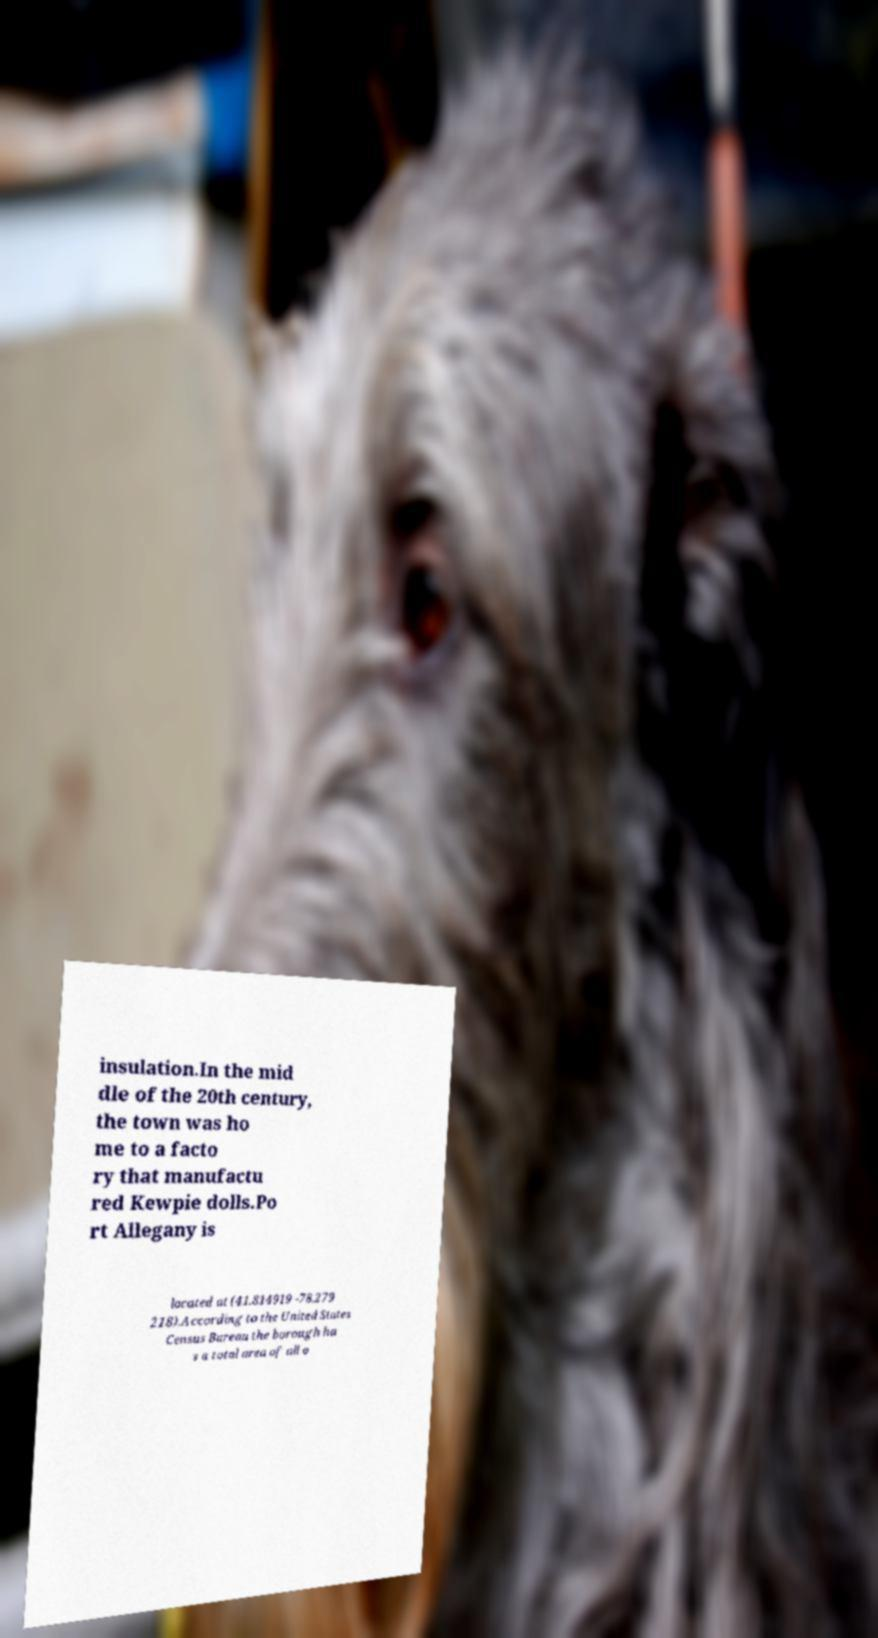Can you read and provide the text displayed in the image?This photo seems to have some interesting text. Can you extract and type it out for me? insulation.In the mid dle of the 20th century, the town was ho me to a facto ry that manufactu red Kewpie dolls.Po rt Allegany is located at (41.814919 -78.279 218).According to the United States Census Bureau the borough ha s a total area of all o 